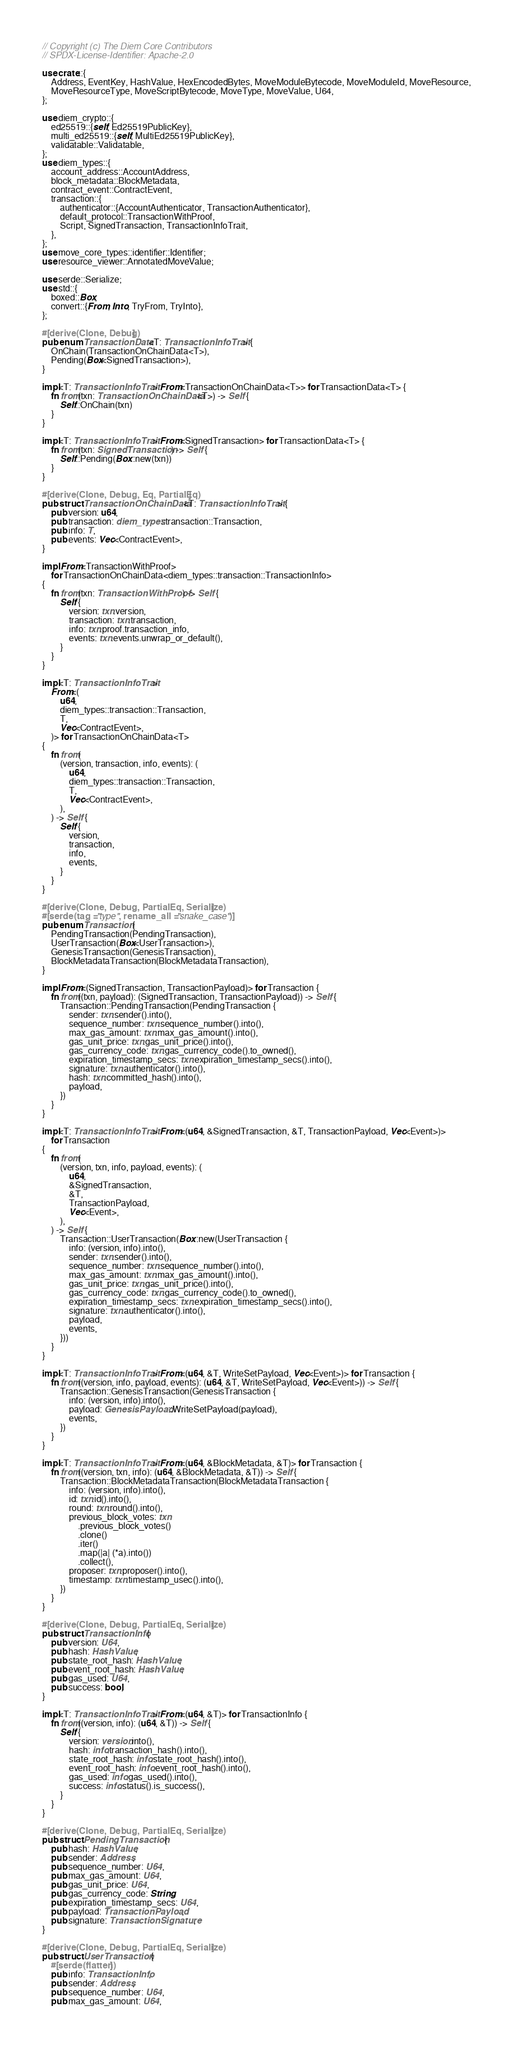Convert code to text. <code><loc_0><loc_0><loc_500><loc_500><_Rust_>// Copyright (c) The Diem Core Contributors
// SPDX-License-Identifier: Apache-2.0

use crate::{
    Address, EventKey, HashValue, HexEncodedBytes, MoveModuleBytecode, MoveModuleId, MoveResource,
    MoveResourceType, MoveScriptBytecode, MoveType, MoveValue, U64,
};

use diem_crypto::{
    ed25519::{self, Ed25519PublicKey},
    multi_ed25519::{self, MultiEd25519PublicKey},
    validatable::Validatable,
};
use diem_types::{
    account_address::AccountAddress,
    block_metadata::BlockMetadata,
    contract_event::ContractEvent,
    transaction::{
        authenticator::{AccountAuthenticator, TransactionAuthenticator},
        default_protocol::TransactionWithProof,
        Script, SignedTransaction, TransactionInfoTrait,
    },
};
use move_core_types::identifier::Identifier;
use resource_viewer::AnnotatedMoveValue;

use serde::Serialize;
use std::{
    boxed::Box,
    convert::{From, Into, TryFrom, TryInto},
};

#[derive(Clone, Debug)]
pub enum TransactionData<T: TransactionInfoTrait> {
    OnChain(TransactionOnChainData<T>),
    Pending(Box<SignedTransaction>),
}

impl<T: TransactionInfoTrait> From<TransactionOnChainData<T>> for TransactionData<T> {
    fn from(txn: TransactionOnChainData<T>) -> Self {
        Self::OnChain(txn)
    }
}

impl<T: TransactionInfoTrait> From<SignedTransaction> for TransactionData<T> {
    fn from(txn: SignedTransaction) -> Self {
        Self::Pending(Box::new(txn))
    }
}

#[derive(Clone, Debug, Eq, PartialEq)]
pub struct TransactionOnChainData<T: TransactionInfoTrait> {
    pub version: u64,
    pub transaction: diem_types::transaction::Transaction,
    pub info: T,
    pub events: Vec<ContractEvent>,
}

impl From<TransactionWithProof>
    for TransactionOnChainData<diem_types::transaction::TransactionInfo>
{
    fn from(txn: TransactionWithProof) -> Self {
        Self {
            version: txn.version,
            transaction: txn.transaction,
            info: txn.proof.transaction_info,
            events: txn.events.unwrap_or_default(),
        }
    }
}

impl<T: TransactionInfoTrait>
    From<(
        u64,
        diem_types::transaction::Transaction,
        T,
        Vec<ContractEvent>,
    )> for TransactionOnChainData<T>
{
    fn from(
        (version, transaction, info, events): (
            u64,
            diem_types::transaction::Transaction,
            T,
            Vec<ContractEvent>,
        ),
    ) -> Self {
        Self {
            version,
            transaction,
            info,
            events,
        }
    }
}

#[derive(Clone, Debug, PartialEq, Serialize)]
#[serde(tag = "type", rename_all = "snake_case")]
pub enum Transaction {
    PendingTransaction(PendingTransaction),
    UserTransaction(Box<UserTransaction>),
    GenesisTransaction(GenesisTransaction),
    BlockMetadataTransaction(BlockMetadataTransaction),
}

impl From<(SignedTransaction, TransactionPayload)> for Transaction {
    fn from((txn, payload): (SignedTransaction, TransactionPayload)) -> Self {
        Transaction::PendingTransaction(PendingTransaction {
            sender: txn.sender().into(),
            sequence_number: txn.sequence_number().into(),
            max_gas_amount: txn.max_gas_amount().into(),
            gas_unit_price: txn.gas_unit_price().into(),
            gas_currency_code: txn.gas_currency_code().to_owned(),
            expiration_timestamp_secs: txn.expiration_timestamp_secs().into(),
            signature: txn.authenticator().into(),
            hash: txn.committed_hash().into(),
            payload,
        })
    }
}

impl<T: TransactionInfoTrait> From<(u64, &SignedTransaction, &T, TransactionPayload, Vec<Event>)>
    for Transaction
{
    fn from(
        (version, txn, info, payload, events): (
            u64,
            &SignedTransaction,
            &T,
            TransactionPayload,
            Vec<Event>,
        ),
    ) -> Self {
        Transaction::UserTransaction(Box::new(UserTransaction {
            info: (version, info).into(),
            sender: txn.sender().into(),
            sequence_number: txn.sequence_number().into(),
            max_gas_amount: txn.max_gas_amount().into(),
            gas_unit_price: txn.gas_unit_price().into(),
            gas_currency_code: txn.gas_currency_code().to_owned(),
            expiration_timestamp_secs: txn.expiration_timestamp_secs().into(),
            signature: txn.authenticator().into(),
            payload,
            events,
        }))
    }
}

impl<T: TransactionInfoTrait> From<(u64, &T, WriteSetPayload, Vec<Event>)> for Transaction {
    fn from((version, info, payload, events): (u64, &T, WriteSetPayload, Vec<Event>)) -> Self {
        Transaction::GenesisTransaction(GenesisTransaction {
            info: (version, info).into(),
            payload: GenesisPayload::WriteSetPayload(payload),
            events,
        })
    }
}

impl<T: TransactionInfoTrait> From<(u64, &BlockMetadata, &T)> for Transaction {
    fn from((version, txn, info): (u64, &BlockMetadata, &T)) -> Self {
        Transaction::BlockMetadataTransaction(BlockMetadataTransaction {
            info: (version, info).into(),
            id: txn.id().into(),
            round: txn.round().into(),
            previous_block_votes: txn
                .previous_block_votes()
                .clone()
                .iter()
                .map(|a| (*a).into())
                .collect(),
            proposer: txn.proposer().into(),
            timestamp: txn.timestamp_usec().into(),
        })
    }
}

#[derive(Clone, Debug, PartialEq, Serialize)]
pub struct TransactionInfo {
    pub version: U64,
    pub hash: HashValue,
    pub state_root_hash: HashValue,
    pub event_root_hash: HashValue,
    pub gas_used: U64,
    pub success: bool,
}

impl<T: TransactionInfoTrait> From<(u64, &T)> for TransactionInfo {
    fn from((version, info): (u64, &T)) -> Self {
        Self {
            version: version.into(),
            hash: info.transaction_hash().into(),
            state_root_hash: info.state_root_hash().into(),
            event_root_hash: info.event_root_hash().into(),
            gas_used: info.gas_used().into(),
            success: info.status().is_success(),
        }
    }
}

#[derive(Clone, Debug, PartialEq, Serialize)]
pub struct PendingTransaction {
    pub hash: HashValue,
    pub sender: Address,
    pub sequence_number: U64,
    pub max_gas_amount: U64,
    pub gas_unit_price: U64,
    pub gas_currency_code: String,
    pub expiration_timestamp_secs: U64,
    pub payload: TransactionPayload,
    pub signature: TransactionSignature,
}

#[derive(Clone, Debug, PartialEq, Serialize)]
pub struct UserTransaction {
    #[serde(flatten)]
    pub info: TransactionInfo,
    pub sender: Address,
    pub sequence_number: U64,
    pub max_gas_amount: U64,</code> 